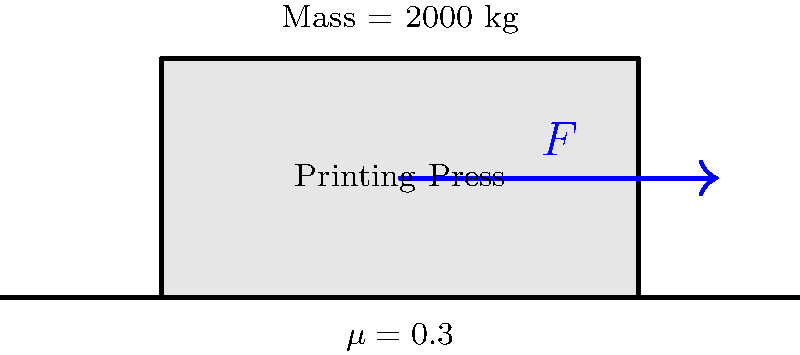A large printing press with a mass of 2000 kg needs to be moved across a flat floor. The coefficient of friction between the press and the floor is 0.3. What is the minimum horizontal force $F$ required to start moving the printing press? To solve this problem, we'll follow these steps:

1) First, we need to calculate the normal force. Since the press is on a flat surface, the normal force is equal to the weight of the press:

   $N = mg$, where $m$ is the mass and $g$ is the acceleration due to gravity (9.8 m/s²)
   
   $N = 2000 \text{ kg} \times 9.8 \text{ m/s²} = 19600 \text{ N}$

2) Next, we calculate the force of friction. The coefficient of friction is given as $\mu = 0.3$:

   $F_f = \mu N = 0.3 \times 19600 \text{ N} = 5880 \text{ N}$

3) To start moving the press, we need to apply a force that is just slightly greater than the force of friction. Therefore, the minimum force required is equal to the force of friction:

   $F = F_f = 5880 \text{ N}$

Thus, a horizontal force of 5880 N is required to start moving the printing press.
Answer: 5880 N 